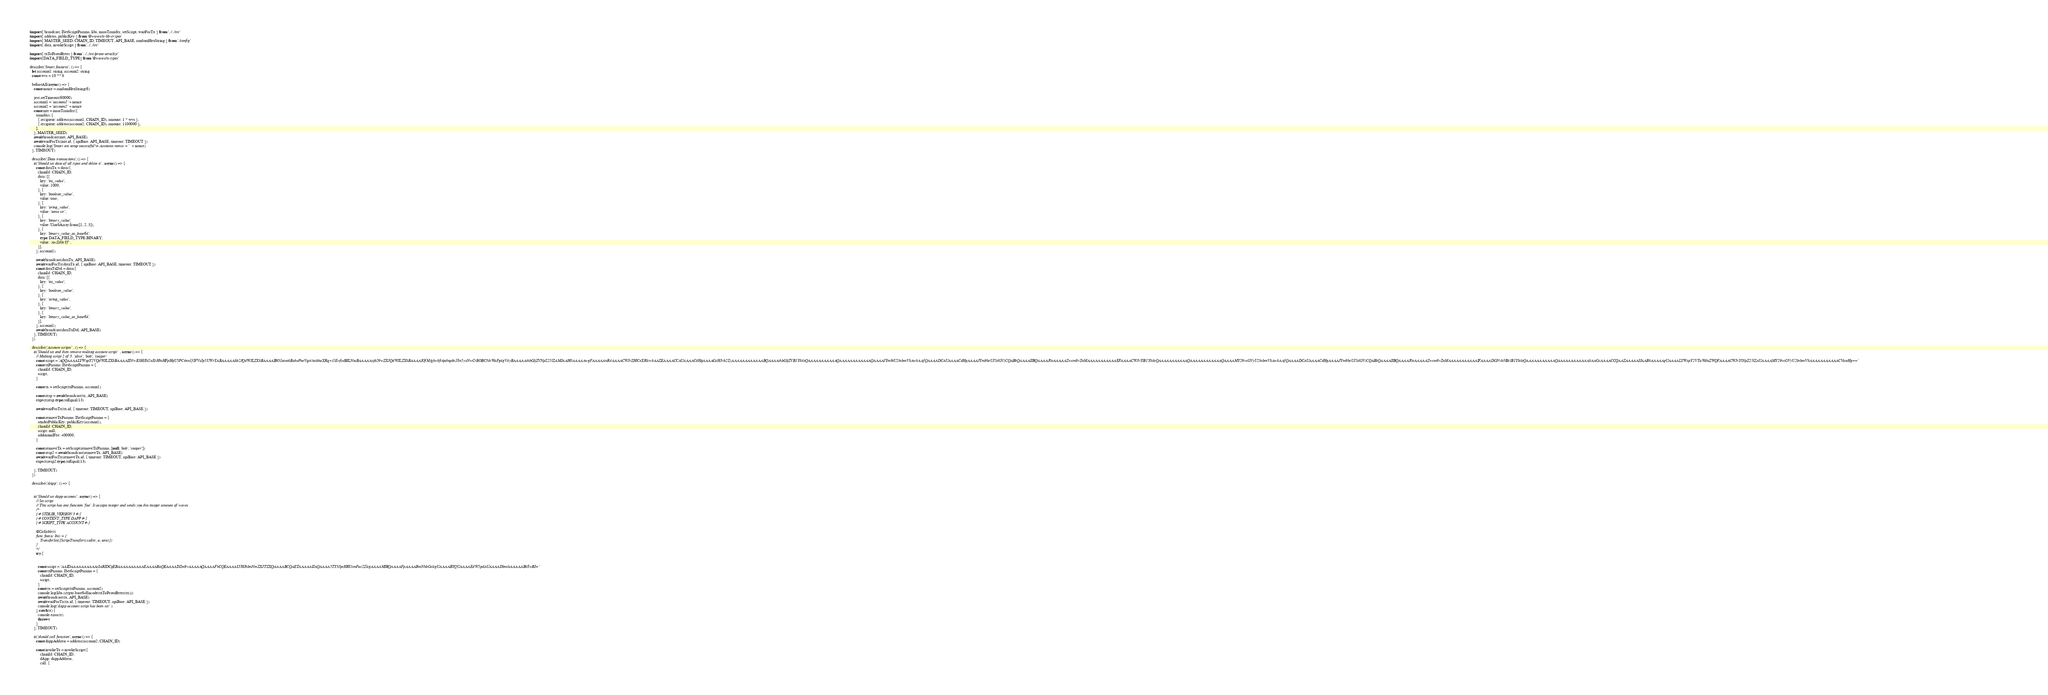Convert code to text. <code><loc_0><loc_0><loc_500><loc_500><_TypeScript_>import { broadcast, ISetScriptParams, libs, massTransfer, setScript, waitForTx } from '../../src'
import { address, publicKey } from '@waves/ts-lib-crypto'
import { MASTER_SEED, CHAIN_ID, TIMEOUT, API_BASE, randomHexString } from './config'
import { data, invokeScript } from '../../src'

import { txToProtoBytes } from '../../src/proto-serialize'
import {DATA_FIELD_TYPE} from '@waves/ts-types'

describe('Smart features', () => {
  let account1: string, account2: string
  const wvs = 10 ** 8

  beforeAll(async () => {
    const nonce = randomHexString(6)

    jest.setTimeout(60000)
    account1 = 'account1' + nonce
    account2 = 'account2' + nonce
    const mtt = massTransfer({
      transfers: [
        { recipient: address(account1, CHAIN_ID), amount: 1 * wvs },
        { recipient: address(account2, CHAIN_ID), amount: 1100000 },
      ],
    }, MASTER_SEED)
    await broadcast(mtt, API_BASE)
    await waitForTx(mtt.id, { apiBase: API_BASE, timeout: TIMEOUT })
    console.log('Smart test setup successful\n Accounts nonce = ' + nonce)
  }, TIMEOUT)

  describe('Data transactions', () => {
    it('Should set data of all types and delete it', async () => {
      const dataTx = data({
        chainId: CHAIN_ID,
        data: [{
          key: 'int_value',
          value: 1000,
        }, {
          key: 'boolean_value',
          value: true,
        }, {
          key: 'string_value',
          value: 'some str',
        }, {
          key: 'binary_value',
          value: Uint8Array.from([1, 2, 3]),
        }, {
          key: 'binary_value_as_base64',
          type: DATA_FIELD_TYPE.BINARY,
          value: 'AwZd0cYf',
        }],
      }, account1)

      await broadcast(dataTx, API_BASE)
      await waitForTx(dataTx.id, { apiBase: API_BASE, timeout: TIMEOUT })
      const dataTxDel = data({
        chainId: CHAIN_ID,
        data: [{
          key: 'int_value',
        }, {
          key: 'boolean_value',
        }, {
          key: 'string_value',
        }, {
          key: 'binary_value',
        }, {
          key: 'binary_value_as_base64',
        }],
      }, account1)
      await broadcast(dataTxDel, API_BASE)
    }, TIMEOUT)
  })

  describe('Account scripts', () => {
    it('Should set and then remove multisig account script', async () => {
      // Multisig script 2 of 3. 'alice', 'bob', 'cooper'
      const script = 'AQQAAAALYWxpY2VQdWJLZXkBAAAAID3+K0HJI42oXrHhtHFpHijU5PC4nn1fIFVsJp5UWrYABAAAAAlib2JQdWJLZXkBAAAAIBO1uieokBahePoeVqt4/usbhaXRq+i5EvtfsdBILNtuBAAAAAxjb29wZXJQdWJLZXkBAAAAIOfM/qkwkfi4pdngdn18n5yxNwCrBOBC3ihWaFg4gV4yBAAAAAthbGljZVNpZ25lZAMJAAH0AAAAAwgFAAAAAnR4AAAACWJvZHlCeXRlcwkAAZEAAAACCAUAAAACdHgAAAAGcHJvb2ZzAAAAAAAAAAAABQAAAAthbGljZVB1YktleQAAAAAAAAAAAQAAAAAAAAAAAAQAAAAJYm9iU2lnbmVkAwkAAfQAAAADCAUAAAACdHgAAAAJYm9keUJ5dGVzCQABkQAAAAIIBQAAAAJ0eAAAAAZwcm9vZnMAAAAAAAAAAAEFAAAACWJvYlB1YktleQAAAAAAAAAAAQAAAAAAAAAAAAQAAAAMY29vcGVyU2lnbmVkAwkAAfQAAAADCAUAAAACdHgAAAAJYm9keUJ5dGVzCQABkQAAAAIIBQAAAAJ0eAAAAAZwcm9vZnMAAAAAAAAAAAIFAAAADGNvb3BlclB1YktleQAAAAAAAAAAAQAAAAAAAAAAAAkAAGcAAAACCQAAZAAAAAIJAABkAAAAAgUAAAALYWxpY2VTaWduZWQFAAAACWJvYlNpZ25lZAUAAAAMY29vcGVyU2lnbmVkAAAAAAAAAAACVateHg=='
      const txParams: ISetScriptParams = {
        chainId: CHAIN_ID,
        script,
      }

      const tx = setScript(txParams, account1)

      const resp = await broadcast(tx, API_BASE)
      expect(resp.type).toEqual(13)

      await waitForTx(tx.id, { timeout: TIMEOUT, apiBase: API_BASE })

      const removeTxParams: ISetScriptParams = {
        senderPublicKey: publicKey(account1),
        chainId: CHAIN_ID,
        script: null,
        additionalFee: 400000,
      }

      const removeTx = setScript(removeTxParams, [null, 'bob', 'cooper'])
      const resp2 = await broadcast(removeTx, API_BASE)
      await waitForTx(removeTx.id, { timeout: TIMEOUT, apiBase: API_BASE })
      expect(resp2.type).toEqual(13)

    }, TIMEOUT)
  })

  describe('dApp', () => {


    it('Should set dapp account', async () => {
      // Set script
      // This script has one function 'foo'. It accepts integer and sends you this integer amount of waves
      /*
      {-# STDLIB_VERSION 3 #-}
      {-# CONTENT_TYPE DAPP #-}
      {-# SCRIPT_TYPE ACCOUNT #-}

      @Callable(i)
      func foo(a: Int) = {
          TransferSet([ScriptTransfer(i.caller, a, unit)])
      }
      */
      try {


        const script = 'AAIDAAAAAAAAAAcIARIDCgEBAAAAAAAAAAEAAAABaQEAAAADZm9vAAAAAQAAAAFhCQEAAAALVHJhbnNmZXJTZXQAAAABCQAETAAAAAIJAQAAAA5TY3JpcHRUcmFuc2ZlcgAAAAMIBQAAAAFpAAAABmNhbGxlcgUAAAABYQUAAAAEdW5pdAUAAAADbmlsAAAAABk8wBI='
        const txParams: ISetScriptParams = {
          chainId: CHAIN_ID,
          script,
        }
        const tx = setScript(txParams, account2)
        console.log(libs.crypto.base64Encode(txToProtoBytes(tx)))
        await broadcast(tx, API_BASE)
        await waitForTx(tx.id, { timeout: TIMEOUT, apiBase: API_BASE })
        console.log('dApp account script has been set')
      } catch (e) {
        console.error(e)
        throw e
      }
    }, TIMEOUT)

    it('should call function', async () => {
      const dappAddress = address(account2, CHAIN_ID)

      const invokeTx = invokeScript({
          chainId: CHAIN_ID,
          dApp: dappAddress,
          call: {</code> 